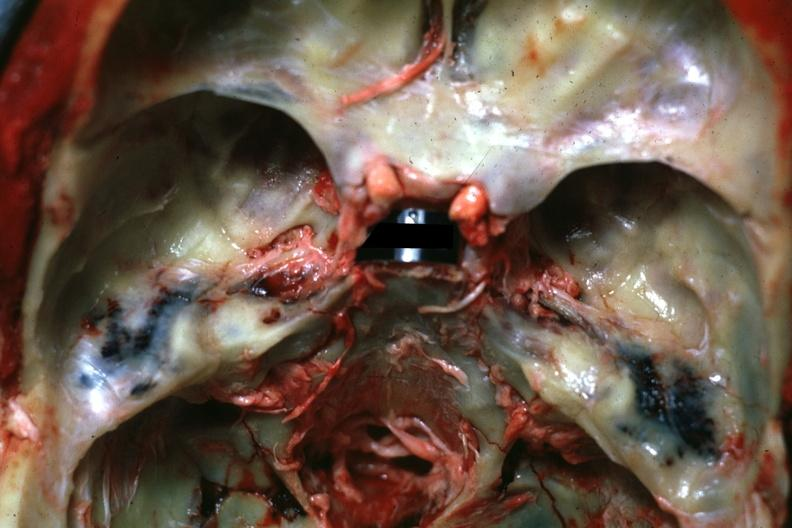s this image present?
Answer the question using a single word or phrase. No 